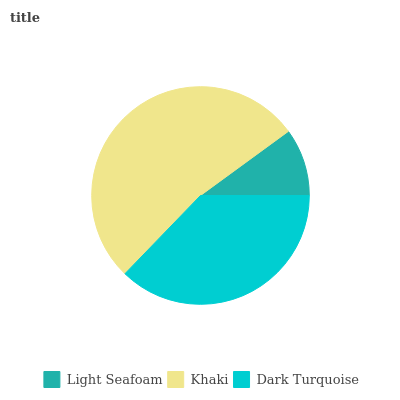Is Light Seafoam the minimum?
Answer yes or no. Yes. Is Khaki the maximum?
Answer yes or no. Yes. Is Dark Turquoise the minimum?
Answer yes or no. No. Is Dark Turquoise the maximum?
Answer yes or no. No. Is Khaki greater than Dark Turquoise?
Answer yes or no. Yes. Is Dark Turquoise less than Khaki?
Answer yes or no. Yes. Is Dark Turquoise greater than Khaki?
Answer yes or no. No. Is Khaki less than Dark Turquoise?
Answer yes or no. No. Is Dark Turquoise the high median?
Answer yes or no. Yes. Is Dark Turquoise the low median?
Answer yes or no. Yes. Is Khaki the high median?
Answer yes or no. No. Is Khaki the low median?
Answer yes or no. No. 